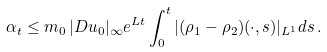<formula> <loc_0><loc_0><loc_500><loc_500>\alpha _ { t } \leq m _ { 0 } \, | D u _ { 0 } | _ { \infty } e ^ { L t } \int _ { 0 } ^ { t } | ( \rho _ { 1 } - \rho _ { 2 } ) ( \cdot , s ) | _ { L ^ { 1 } } d s \, .</formula> 